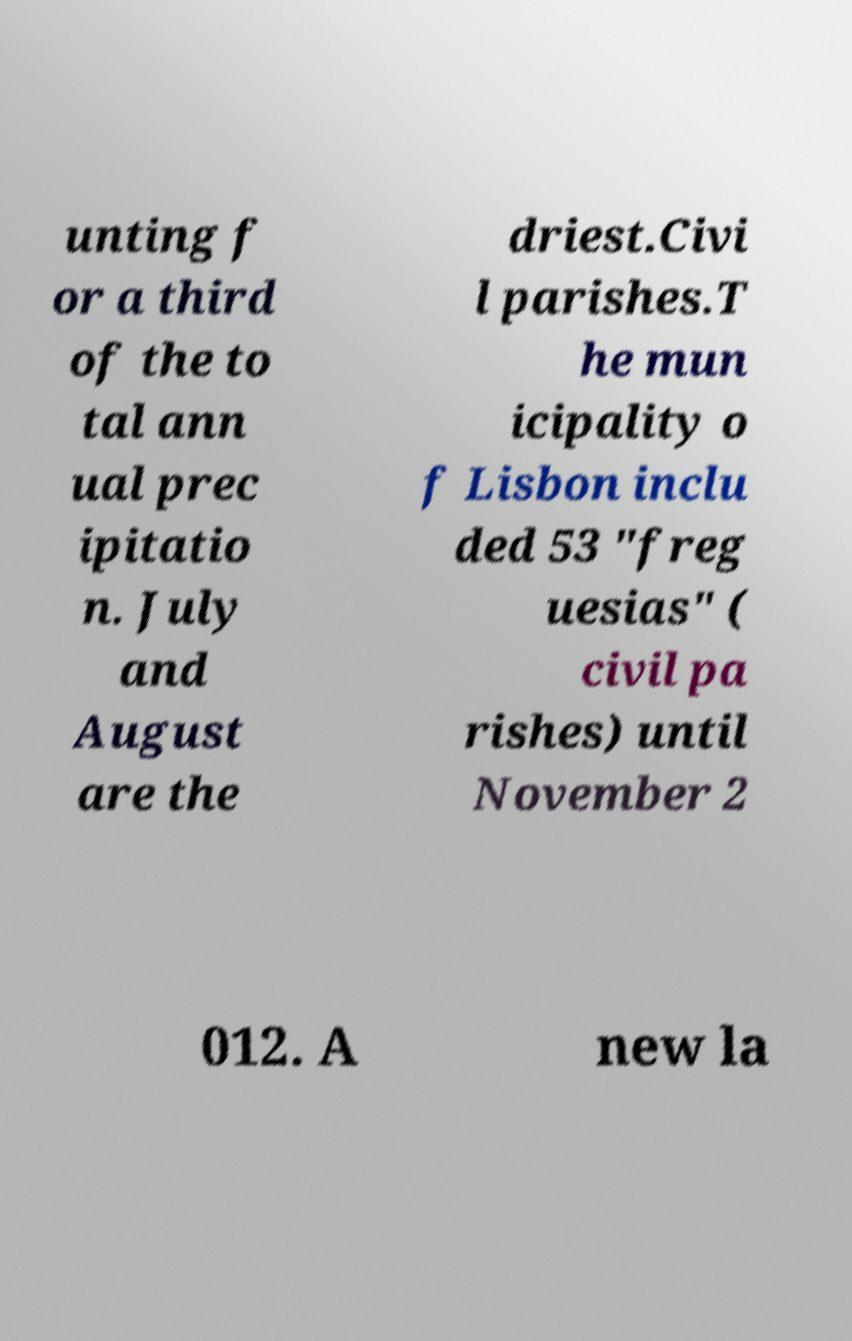Please read and relay the text visible in this image. What does it say? unting f or a third of the to tal ann ual prec ipitatio n. July and August are the driest.Civi l parishes.T he mun icipality o f Lisbon inclu ded 53 "freg uesias" ( civil pa rishes) until November 2 012. A new la 